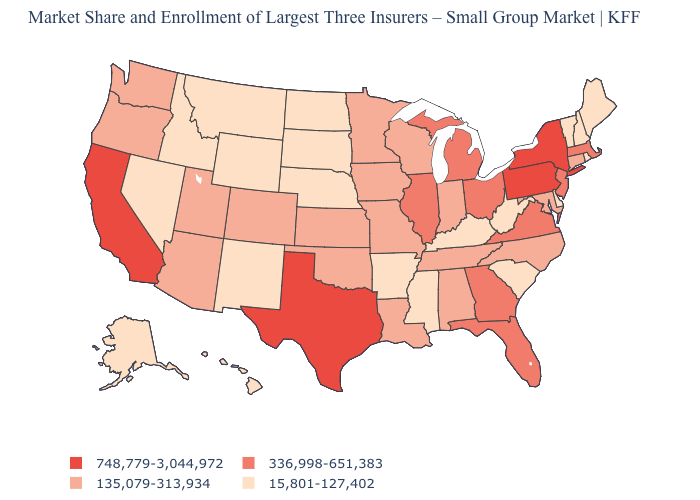Does New York have the lowest value in the USA?
Give a very brief answer. No. What is the value of New Jersey?
Short answer required. 336,998-651,383. What is the value of Rhode Island?
Be succinct. 15,801-127,402. Which states hav the highest value in the South?
Keep it brief. Texas. What is the lowest value in the MidWest?
Be succinct. 15,801-127,402. What is the lowest value in states that border Louisiana?
Be succinct. 15,801-127,402. Does Idaho have the lowest value in the USA?
Short answer required. Yes. Name the states that have a value in the range 748,779-3,044,972?
Give a very brief answer. California, New York, Pennsylvania, Texas. Does Georgia have the same value as Virginia?
Keep it brief. Yes. Among the states that border New Hampshire , does Massachusetts have the lowest value?
Be succinct. No. Name the states that have a value in the range 135,079-313,934?
Write a very short answer. Alabama, Arizona, Colorado, Connecticut, Indiana, Iowa, Kansas, Louisiana, Maryland, Minnesota, Missouri, North Carolina, Oklahoma, Oregon, Tennessee, Utah, Washington, Wisconsin. Name the states that have a value in the range 15,801-127,402?
Answer briefly. Alaska, Arkansas, Delaware, Hawaii, Idaho, Kentucky, Maine, Mississippi, Montana, Nebraska, Nevada, New Hampshire, New Mexico, North Dakota, Rhode Island, South Carolina, South Dakota, Vermont, West Virginia, Wyoming. What is the value of Iowa?
Give a very brief answer. 135,079-313,934. Does Ohio have the highest value in the MidWest?
Concise answer only. Yes. What is the lowest value in states that border Nevada?
Concise answer only. 15,801-127,402. 